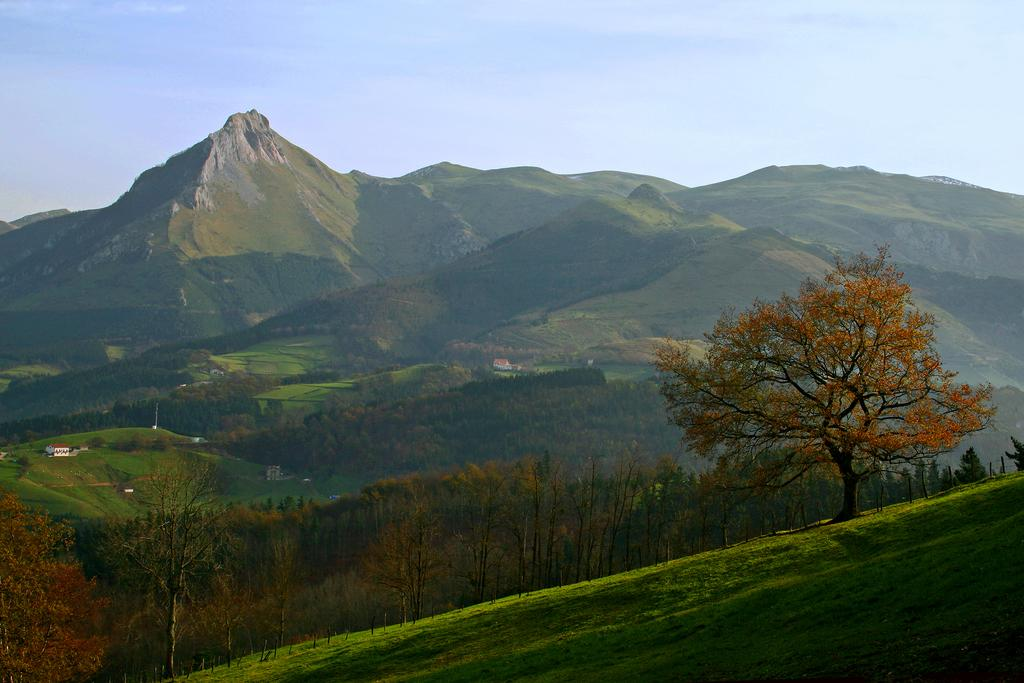What type of natural landform can be seen in the image? There are mountains in the image. What type of vegetation is present in the image? There are trees in the image. What type of ground cover can be seen in the image? There is grass on the surface in the image. How many matches are visible in the image? There are no matches present in the image. What type of passenger can be seen in the image? There are no passengers present in the image. 